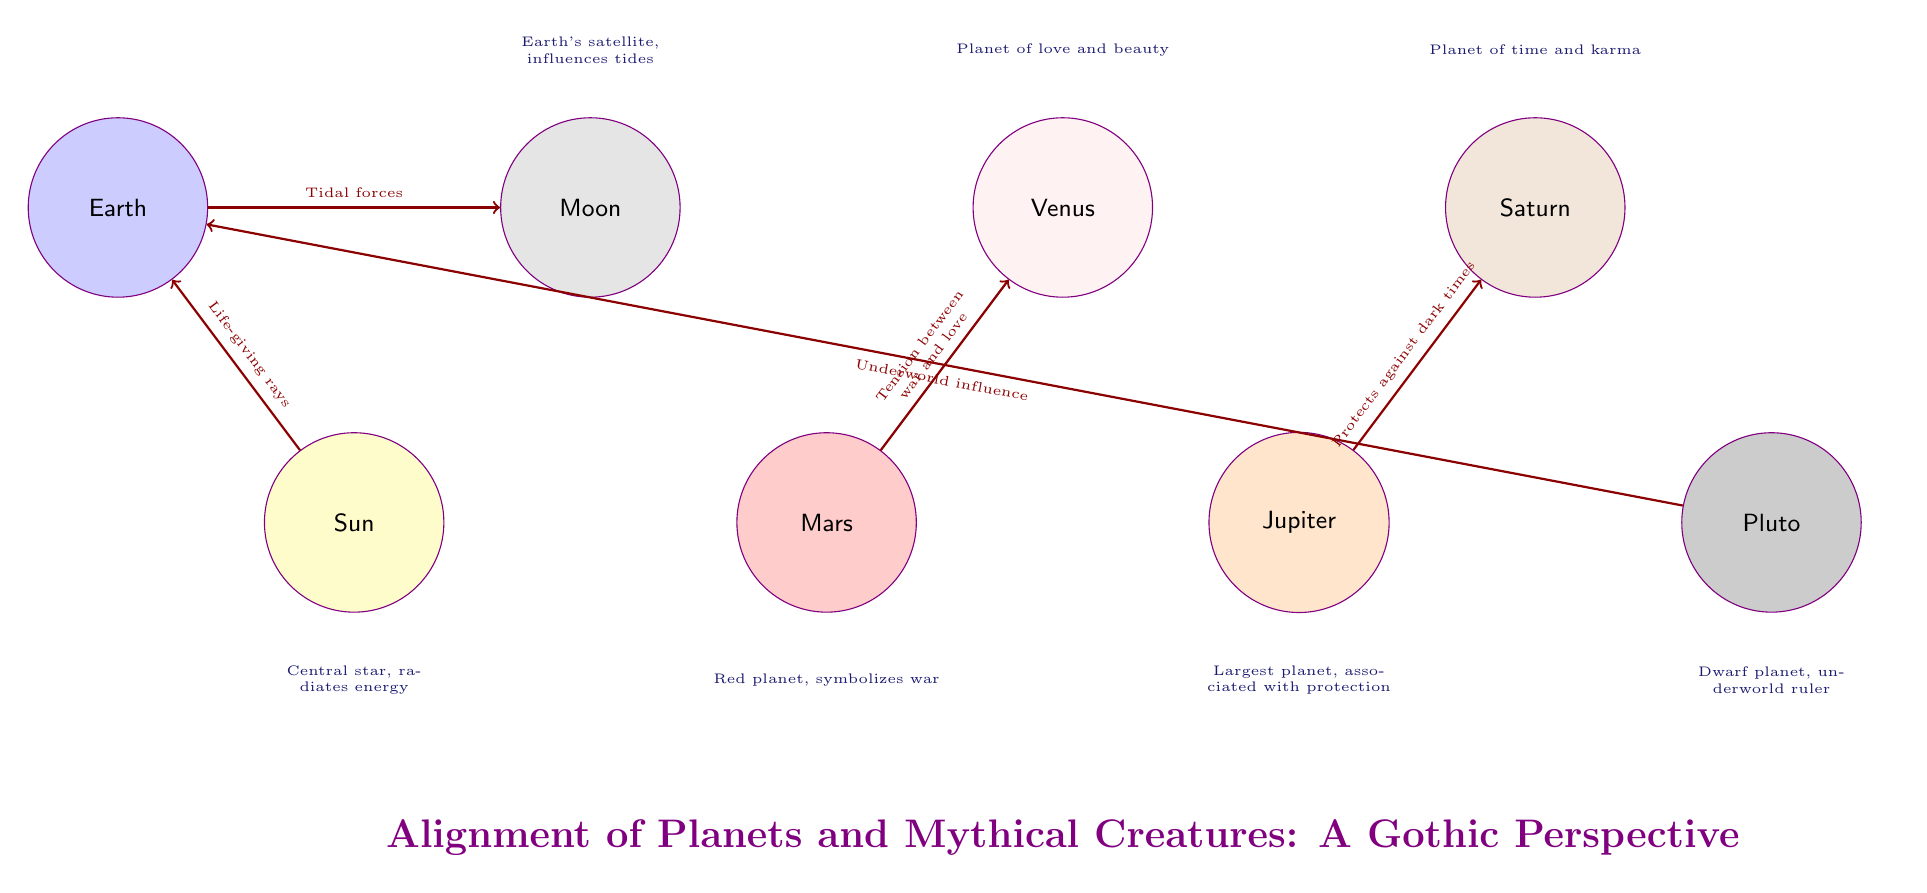What is the color of the Sun node in the diagram? The Sun node is drawn with a yellow fill color, as visually indicated in its representation.
Answer: yellow How many nodes represent planets in this diagram? Counting all the circular nodes in the diagram that represent planets, we find Mars, Venus, Jupiter, Saturn, and Pluto. This totals five nodes.
Answer: 5 What relationship is depicted between Earth and the Moon? The diagram shows an arrow flowing from Earth to the Moon, indicating the Moon's influence on the tides, which is described in the connected text on the arrow.
Answer: Tidal forces Which planet symbolizes war according to this diagram? Looking at the node labels, Mars is labeled as the "Red planet, symbolizes war," indicating its connection to the theme of war.
Answer: Mars What color is the Moon node? The Moon node is filled with a gray color, as indicated in the visual representation of the Moon.
Answer: gray What connection does Jupiter have with Saturn? There is a directed arrow from Jupiter to Saturn in the diagram, and the accompanying text describes this connection as "Protects against dark times," indicating Jupiter's protective aspect toward Saturn.
Answer: Protects against dark times Which node is positioned farthest to the right? The node located at the farthest right in the diagram is Pluto, which is labeled as a dwarf planet and ruler of the underworld.
Answer: Pluto How many edges are present in the diagram? Each directed relationship between the nodes is represented by an arrow, counted individually for each connection provided in the diagram. There are six arrows shown.
Answer: 6 What influences does Pluto exert according to the diagram? The diagram includes an arrow from Pluto to Earth, accompanied by the phrase "Underworld influence," which indicates the influence Pluto exerts according to the diagram.
Answer: Underworld influence 